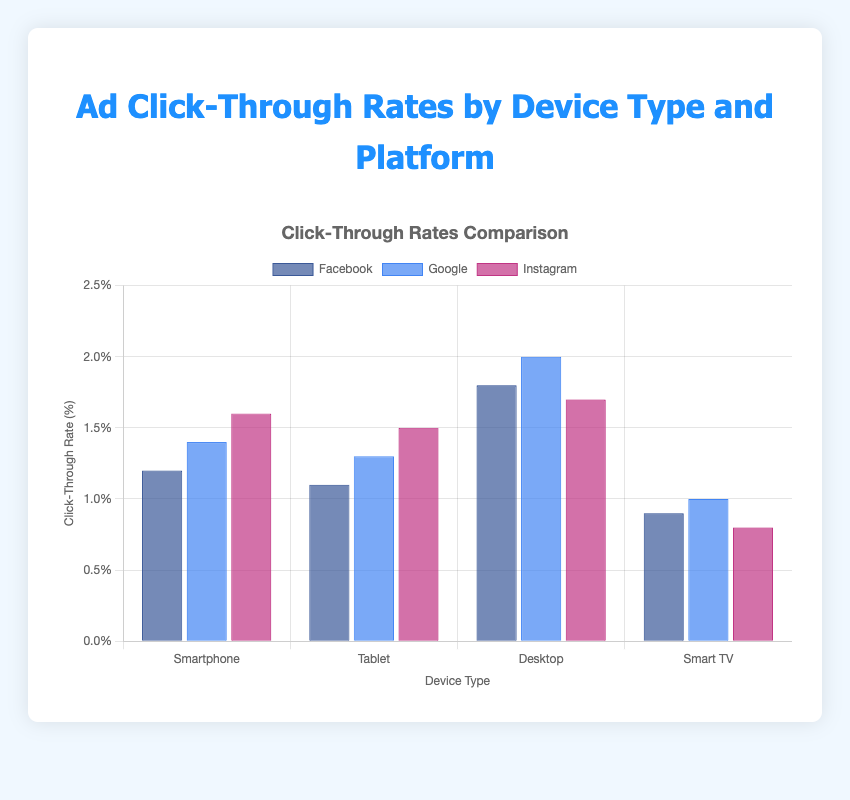What device type has the highest click-through rate (CTR) on Facebook? The bar chart shows the CTRs for Facebook across different device types. By looking at the height of the bars for Facebook, the Desktop has the highest CTR at 1.8%.
Answer: Desktop Between Tablet and Smartphone, which has a higher click-through rate (CTR) on Google? Comparing the height of the Google bars for Tablet and Smartphone, Tablet has a CTR of 1.3% while Smartphone has a higher CTR of 1.4%.
Answer: Smartphone Which platform shows the lowest click-through rate (CTR) for Smart Tv? Observing the bars for Smart TV, the Instagram bar is the shortest with a CTR of 0.8%.
Answer: Instagram What is the total click-through rate (CTR) for Facebook ads across all device types? The CTRs for Facebook are: Smartphone (1.2%), Tablet (1.1%), Desktop (1.8%), and Smart TV (0.9%). Summing these up: 1.2 + 1.1 + 1.8 + 0.9 = 5.0%.
Answer: 5.0% Which device type has the highest overall click-through rate (CTR) when summing across all platforms? Summing the CTRs for each device across all platforms: Smartphone (1.2 + 1.4 + 1.6), Tablet (1.1 + 1.3 + 1.5), Desktop (1.8 + 2.0 + 1.7), and Smart TV (0.9 + 1.0 + 0.8). Calculations: Smartphone (4.2%), Tablet (3.9%), Desktop (5.5%), and Smart TV (2.7%). Desktop has the highest total CTR of 5.5%.
Answer: Desktop Is the CTR on Instagram higher for Tablets or Smartphones? Checking the height of the bars for Instagram on both Tablets and Smartphones, we find Tablet has a CTR of 1.5%, while Smartphone has a CTR of 1.6%.
Answer: Smartphone What is the average click-through rate (CTR) for all platforms on Desktops? Summing the CTRs for Desktop across all platforms (1.8 + 2.0 + 1.7) and dividing by 3 (number of platforms): (1.8 + 2.0 + 1.7) / 3 = 1.833%.
Answer: 1.833% By how much does the click-through rate (CTR) for Google on Smart Tv exceed that of Instagram on Smartphones? The CTR for Google on Smart TV is 1.0%, and for Instagram on Smartphones is 1.6%. The difference is 1.6% - 1.0% = 0.6%.
Answer: 0.6% Which platform has the most consistent click-through rate (CTR) across all device types? Observing the spread of CTR values for each platform across device types: Facebook (0.9% to 1.8%), Google (1.0% to 2.0%), Instagram (0.8% to 1.7%). Google has the smallest range (1.0% to 2.0%), making it the most consistent.
Answer: Google Compare the average click-through rates (CTR) of Facebook and Instagram across all device types. Which one is higher? To find the average CTR:
For Facebook: (1.2% + 1.1% + 1.8% + 0.9%) / 4 = 1.25%.
For Instagram: (1.6% + 1.5% + 1.7% + 0.8%) / 4 = 1.4%.
Instagram has a higher average CTR than Facebook.
Answer: Instagram 